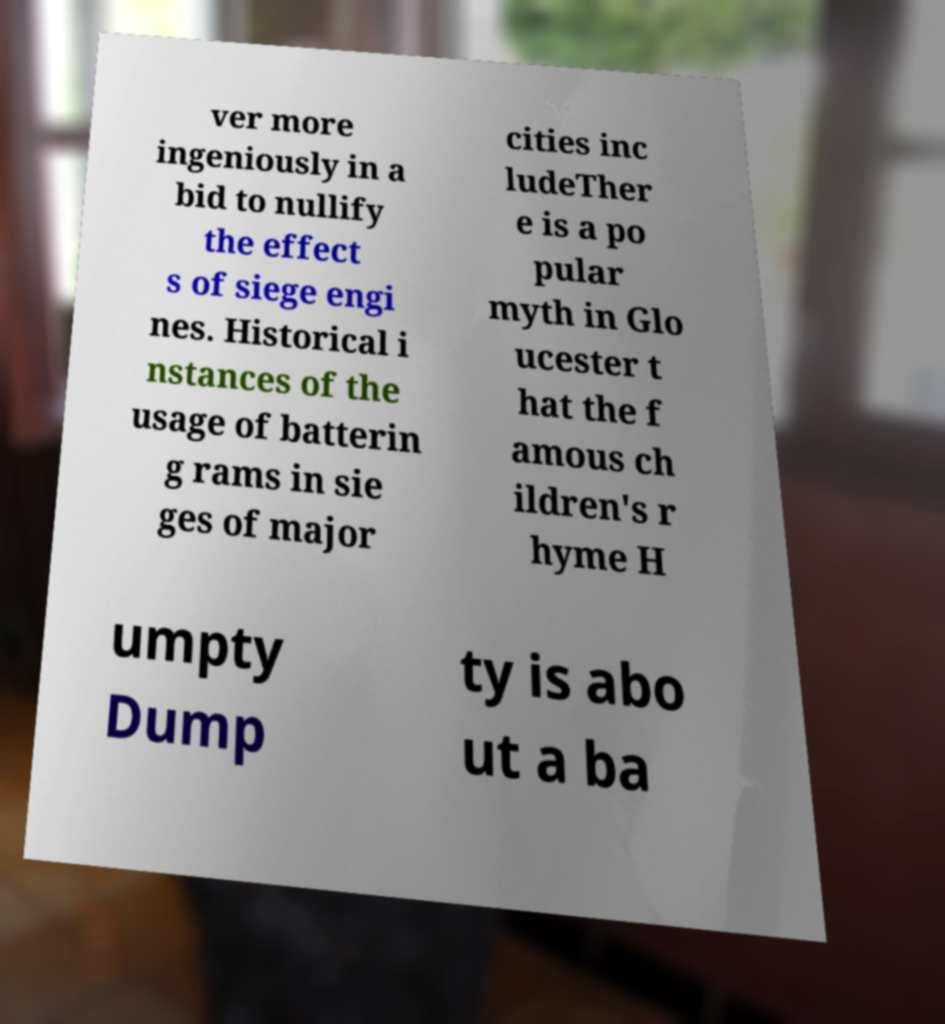Can you accurately transcribe the text from the provided image for me? ver more ingeniously in a bid to nullify the effect s of siege engi nes. Historical i nstances of the usage of batterin g rams in sie ges of major cities inc ludeTher e is a po pular myth in Glo ucester t hat the f amous ch ildren's r hyme H umpty Dump ty is abo ut a ba 